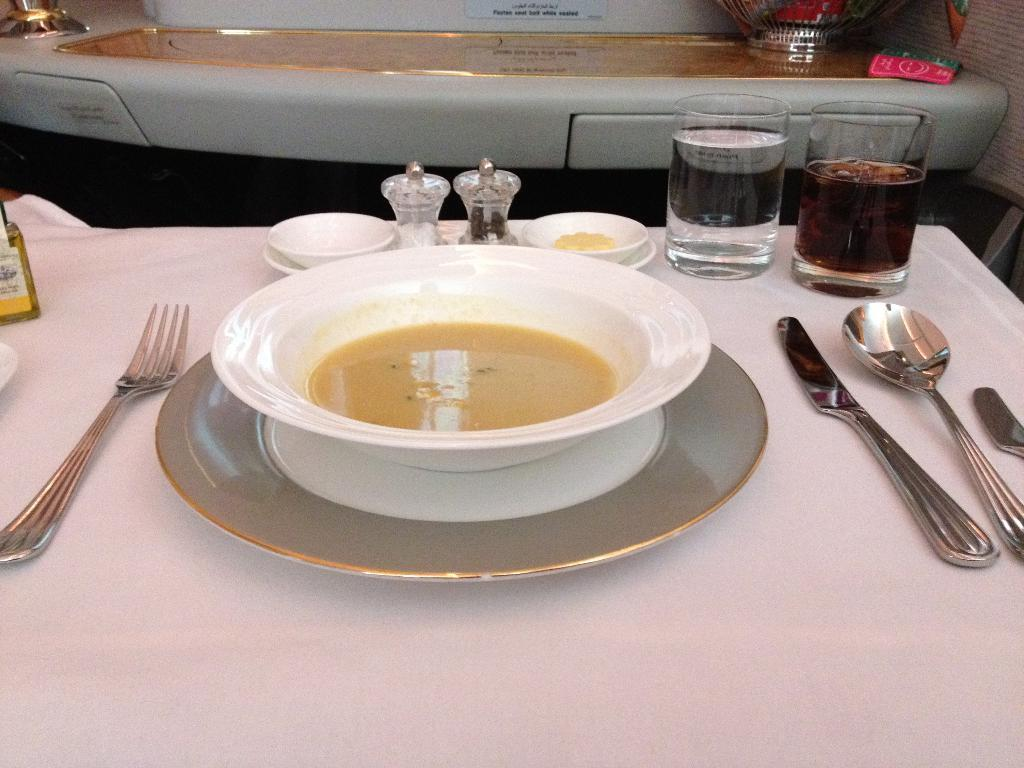What type of furniture is present in the image? There is a table in the image. What utensils can be seen on the table? There is a fork, a knife, and a spoon on the table. What type of dishware is present on the table? There are glasses and bowls on the table. What type of container is on the table? There is a bottle on the table. What else is on the table besides utensils, dishware, and the container? There are food items on the table. Can you describe the background of the image? There is another table in the background of the image. Where is the vest hanging in the image? There is no vest present in the image. Can you describe the garden visible in the image? There is no garden visible in the image. 